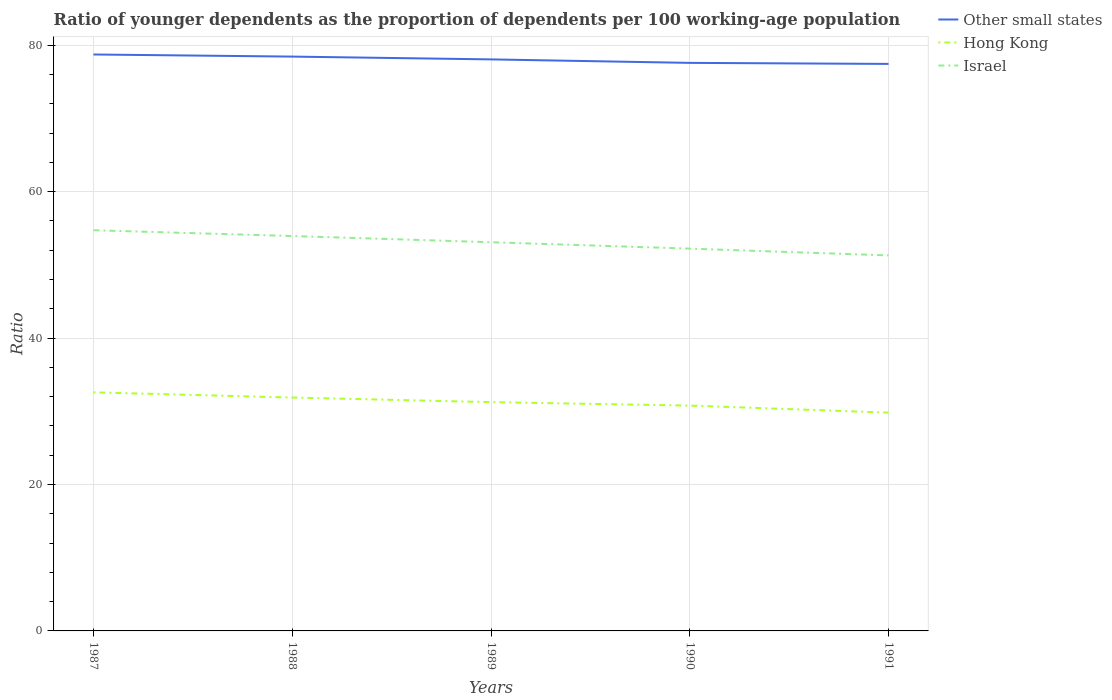Does the line corresponding to Hong Kong intersect with the line corresponding to Israel?
Ensure brevity in your answer.  No. Across all years, what is the maximum age dependency ratio(young) in Other small states?
Provide a short and direct response. 77.45. What is the total age dependency ratio(young) in Israel in the graph?
Ensure brevity in your answer.  2.65. What is the difference between the highest and the second highest age dependency ratio(young) in Israel?
Provide a short and direct response. 3.44. Is the age dependency ratio(young) in Israel strictly greater than the age dependency ratio(young) in Other small states over the years?
Give a very brief answer. Yes. How many lines are there?
Your answer should be compact. 3. How many years are there in the graph?
Offer a very short reply. 5. Are the values on the major ticks of Y-axis written in scientific E-notation?
Provide a short and direct response. No. Does the graph contain any zero values?
Keep it short and to the point. No. Where does the legend appear in the graph?
Give a very brief answer. Top right. How are the legend labels stacked?
Offer a very short reply. Vertical. What is the title of the graph?
Provide a succinct answer. Ratio of younger dependents as the proportion of dependents per 100 working-age population. What is the label or title of the Y-axis?
Your response must be concise. Ratio. What is the Ratio in Other small states in 1987?
Ensure brevity in your answer.  78.74. What is the Ratio in Hong Kong in 1987?
Give a very brief answer. 32.59. What is the Ratio of Israel in 1987?
Your answer should be compact. 54.73. What is the Ratio in Other small states in 1988?
Make the answer very short. 78.45. What is the Ratio in Hong Kong in 1988?
Offer a terse response. 31.88. What is the Ratio of Israel in 1988?
Offer a terse response. 53.94. What is the Ratio of Other small states in 1989?
Your answer should be very brief. 78.07. What is the Ratio of Hong Kong in 1989?
Your answer should be very brief. 31.25. What is the Ratio in Israel in 1989?
Your answer should be very brief. 53.09. What is the Ratio in Other small states in 1990?
Your response must be concise. 77.59. What is the Ratio of Hong Kong in 1990?
Ensure brevity in your answer.  30.78. What is the Ratio in Israel in 1990?
Your response must be concise. 52.22. What is the Ratio of Other small states in 1991?
Offer a very short reply. 77.45. What is the Ratio of Hong Kong in 1991?
Your answer should be compact. 29.82. What is the Ratio of Israel in 1991?
Offer a very short reply. 51.29. Across all years, what is the maximum Ratio of Other small states?
Your answer should be very brief. 78.74. Across all years, what is the maximum Ratio of Hong Kong?
Ensure brevity in your answer.  32.59. Across all years, what is the maximum Ratio in Israel?
Provide a succinct answer. 54.73. Across all years, what is the minimum Ratio in Other small states?
Offer a very short reply. 77.45. Across all years, what is the minimum Ratio in Hong Kong?
Provide a short and direct response. 29.82. Across all years, what is the minimum Ratio in Israel?
Give a very brief answer. 51.29. What is the total Ratio in Other small states in the graph?
Your response must be concise. 390.29. What is the total Ratio of Hong Kong in the graph?
Offer a terse response. 156.31. What is the total Ratio of Israel in the graph?
Give a very brief answer. 265.27. What is the difference between the Ratio in Other small states in 1987 and that in 1988?
Offer a very short reply. 0.29. What is the difference between the Ratio in Hong Kong in 1987 and that in 1988?
Your response must be concise. 0.71. What is the difference between the Ratio of Israel in 1987 and that in 1988?
Provide a succinct answer. 0.79. What is the difference between the Ratio in Other small states in 1987 and that in 1989?
Provide a succinct answer. 0.67. What is the difference between the Ratio of Hong Kong in 1987 and that in 1989?
Offer a very short reply. 1.34. What is the difference between the Ratio in Israel in 1987 and that in 1989?
Provide a succinct answer. 1.64. What is the difference between the Ratio of Other small states in 1987 and that in 1990?
Keep it short and to the point. 1.15. What is the difference between the Ratio in Hong Kong in 1987 and that in 1990?
Provide a succinct answer. 1.81. What is the difference between the Ratio of Israel in 1987 and that in 1990?
Give a very brief answer. 2.51. What is the difference between the Ratio in Other small states in 1987 and that in 1991?
Provide a short and direct response. 1.29. What is the difference between the Ratio in Hong Kong in 1987 and that in 1991?
Offer a very short reply. 2.77. What is the difference between the Ratio of Israel in 1987 and that in 1991?
Offer a very short reply. 3.44. What is the difference between the Ratio in Other small states in 1988 and that in 1989?
Ensure brevity in your answer.  0.38. What is the difference between the Ratio in Hong Kong in 1988 and that in 1989?
Provide a succinct answer. 0.63. What is the difference between the Ratio in Israel in 1988 and that in 1989?
Provide a succinct answer. 0.85. What is the difference between the Ratio of Hong Kong in 1988 and that in 1990?
Your answer should be compact. 1.1. What is the difference between the Ratio in Israel in 1988 and that in 1990?
Your answer should be very brief. 1.72. What is the difference between the Ratio in Other small states in 1988 and that in 1991?
Offer a very short reply. 1. What is the difference between the Ratio in Hong Kong in 1988 and that in 1991?
Provide a succinct answer. 2.06. What is the difference between the Ratio in Israel in 1988 and that in 1991?
Your answer should be compact. 2.65. What is the difference between the Ratio of Other small states in 1989 and that in 1990?
Your answer should be compact. 0.48. What is the difference between the Ratio of Hong Kong in 1989 and that in 1990?
Your answer should be very brief. 0.47. What is the difference between the Ratio of Israel in 1989 and that in 1990?
Provide a succinct answer. 0.87. What is the difference between the Ratio of Other small states in 1989 and that in 1991?
Offer a very short reply. 0.62. What is the difference between the Ratio in Hong Kong in 1989 and that in 1991?
Your answer should be very brief. 1.43. What is the difference between the Ratio in Israel in 1989 and that in 1991?
Your response must be concise. 1.8. What is the difference between the Ratio of Other small states in 1990 and that in 1991?
Provide a short and direct response. 0.14. What is the difference between the Ratio of Hong Kong in 1990 and that in 1991?
Give a very brief answer. 0.96. What is the difference between the Ratio of Israel in 1990 and that in 1991?
Make the answer very short. 0.93. What is the difference between the Ratio of Other small states in 1987 and the Ratio of Hong Kong in 1988?
Your answer should be compact. 46.86. What is the difference between the Ratio in Other small states in 1987 and the Ratio in Israel in 1988?
Your response must be concise. 24.8. What is the difference between the Ratio in Hong Kong in 1987 and the Ratio in Israel in 1988?
Make the answer very short. -21.35. What is the difference between the Ratio of Other small states in 1987 and the Ratio of Hong Kong in 1989?
Your answer should be compact. 47.49. What is the difference between the Ratio of Other small states in 1987 and the Ratio of Israel in 1989?
Offer a terse response. 25.64. What is the difference between the Ratio in Hong Kong in 1987 and the Ratio in Israel in 1989?
Offer a very short reply. -20.5. What is the difference between the Ratio of Other small states in 1987 and the Ratio of Hong Kong in 1990?
Offer a terse response. 47.96. What is the difference between the Ratio in Other small states in 1987 and the Ratio in Israel in 1990?
Give a very brief answer. 26.52. What is the difference between the Ratio in Hong Kong in 1987 and the Ratio in Israel in 1990?
Give a very brief answer. -19.63. What is the difference between the Ratio in Other small states in 1987 and the Ratio in Hong Kong in 1991?
Your answer should be compact. 48.92. What is the difference between the Ratio of Other small states in 1987 and the Ratio of Israel in 1991?
Make the answer very short. 27.45. What is the difference between the Ratio of Hong Kong in 1987 and the Ratio of Israel in 1991?
Provide a succinct answer. -18.7. What is the difference between the Ratio in Other small states in 1988 and the Ratio in Hong Kong in 1989?
Your answer should be compact. 47.2. What is the difference between the Ratio of Other small states in 1988 and the Ratio of Israel in 1989?
Keep it short and to the point. 25.36. What is the difference between the Ratio of Hong Kong in 1988 and the Ratio of Israel in 1989?
Your response must be concise. -21.21. What is the difference between the Ratio in Other small states in 1988 and the Ratio in Hong Kong in 1990?
Make the answer very short. 47.67. What is the difference between the Ratio of Other small states in 1988 and the Ratio of Israel in 1990?
Give a very brief answer. 26.23. What is the difference between the Ratio in Hong Kong in 1988 and the Ratio in Israel in 1990?
Offer a very short reply. -20.34. What is the difference between the Ratio in Other small states in 1988 and the Ratio in Hong Kong in 1991?
Your answer should be compact. 48.63. What is the difference between the Ratio of Other small states in 1988 and the Ratio of Israel in 1991?
Provide a succinct answer. 27.16. What is the difference between the Ratio in Hong Kong in 1988 and the Ratio in Israel in 1991?
Your answer should be very brief. -19.41. What is the difference between the Ratio in Other small states in 1989 and the Ratio in Hong Kong in 1990?
Give a very brief answer. 47.29. What is the difference between the Ratio in Other small states in 1989 and the Ratio in Israel in 1990?
Provide a succinct answer. 25.85. What is the difference between the Ratio in Hong Kong in 1989 and the Ratio in Israel in 1990?
Offer a very short reply. -20.97. What is the difference between the Ratio of Other small states in 1989 and the Ratio of Hong Kong in 1991?
Give a very brief answer. 48.25. What is the difference between the Ratio in Other small states in 1989 and the Ratio in Israel in 1991?
Offer a very short reply. 26.78. What is the difference between the Ratio in Hong Kong in 1989 and the Ratio in Israel in 1991?
Offer a very short reply. -20.04. What is the difference between the Ratio of Other small states in 1990 and the Ratio of Hong Kong in 1991?
Keep it short and to the point. 47.77. What is the difference between the Ratio in Other small states in 1990 and the Ratio in Israel in 1991?
Provide a succinct answer. 26.3. What is the difference between the Ratio in Hong Kong in 1990 and the Ratio in Israel in 1991?
Your answer should be very brief. -20.51. What is the average Ratio in Other small states per year?
Offer a terse response. 78.06. What is the average Ratio of Hong Kong per year?
Make the answer very short. 31.26. What is the average Ratio in Israel per year?
Your answer should be very brief. 53.05. In the year 1987, what is the difference between the Ratio of Other small states and Ratio of Hong Kong?
Offer a very short reply. 46.15. In the year 1987, what is the difference between the Ratio in Other small states and Ratio in Israel?
Give a very brief answer. 24.01. In the year 1987, what is the difference between the Ratio of Hong Kong and Ratio of Israel?
Offer a terse response. -22.14. In the year 1988, what is the difference between the Ratio in Other small states and Ratio in Hong Kong?
Offer a very short reply. 46.57. In the year 1988, what is the difference between the Ratio of Other small states and Ratio of Israel?
Provide a short and direct response. 24.51. In the year 1988, what is the difference between the Ratio of Hong Kong and Ratio of Israel?
Offer a terse response. -22.06. In the year 1989, what is the difference between the Ratio in Other small states and Ratio in Hong Kong?
Provide a short and direct response. 46.82. In the year 1989, what is the difference between the Ratio of Other small states and Ratio of Israel?
Make the answer very short. 24.97. In the year 1989, what is the difference between the Ratio of Hong Kong and Ratio of Israel?
Keep it short and to the point. -21.84. In the year 1990, what is the difference between the Ratio in Other small states and Ratio in Hong Kong?
Your response must be concise. 46.81. In the year 1990, what is the difference between the Ratio in Other small states and Ratio in Israel?
Make the answer very short. 25.37. In the year 1990, what is the difference between the Ratio of Hong Kong and Ratio of Israel?
Keep it short and to the point. -21.44. In the year 1991, what is the difference between the Ratio of Other small states and Ratio of Hong Kong?
Make the answer very short. 47.63. In the year 1991, what is the difference between the Ratio in Other small states and Ratio in Israel?
Your answer should be very brief. 26.16. In the year 1991, what is the difference between the Ratio of Hong Kong and Ratio of Israel?
Offer a very short reply. -21.47. What is the ratio of the Ratio in Other small states in 1987 to that in 1988?
Keep it short and to the point. 1. What is the ratio of the Ratio in Hong Kong in 1987 to that in 1988?
Your answer should be very brief. 1.02. What is the ratio of the Ratio in Israel in 1987 to that in 1988?
Provide a short and direct response. 1.01. What is the ratio of the Ratio in Other small states in 1987 to that in 1989?
Make the answer very short. 1.01. What is the ratio of the Ratio in Hong Kong in 1987 to that in 1989?
Offer a very short reply. 1.04. What is the ratio of the Ratio of Israel in 1987 to that in 1989?
Your answer should be very brief. 1.03. What is the ratio of the Ratio of Other small states in 1987 to that in 1990?
Make the answer very short. 1.01. What is the ratio of the Ratio of Hong Kong in 1987 to that in 1990?
Your answer should be compact. 1.06. What is the ratio of the Ratio of Israel in 1987 to that in 1990?
Offer a terse response. 1.05. What is the ratio of the Ratio in Other small states in 1987 to that in 1991?
Offer a very short reply. 1.02. What is the ratio of the Ratio of Hong Kong in 1987 to that in 1991?
Provide a succinct answer. 1.09. What is the ratio of the Ratio in Israel in 1987 to that in 1991?
Keep it short and to the point. 1.07. What is the ratio of the Ratio of Other small states in 1988 to that in 1989?
Provide a succinct answer. 1. What is the ratio of the Ratio of Hong Kong in 1988 to that in 1989?
Your answer should be compact. 1.02. What is the ratio of the Ratio in Israel in 1988 to that in 1989?
Your response must be concise. 1.02. What is the ratio of the Ratio of Other small states in 1988 to that in 1990?
Keep it short and to the point. 1.01. What is the ratio of the Ratio of Hong Kong in 1988 to that in 1990?
Your answer should be compact. 1.04. What is the ratio of the Ratio of Israel in 1988 to that in 1990?
Keep it short and to the point. 1.03. What is the ratio of the Ratio in Other small states in 1988 to that in 1991?
Your response must be concise. 1.01. What is the ratio of the Ratio of Hong Kong in 1988 to that in 1991?
Your response must be concise. 1.07. What is the ratio of the Ratio of Israel in 1988 to that in 1991?
Keep it short and to the point. 1.05. What is the ratio of the Ratio in Other small states in 1989 to that in 1990?
Offer a terse response. 1.01. What is the ratio of the Ratio of Hong Kong in 1989 to that in 1990?
Give a very brief answer. 1.02. What is the ratio of the Ratio of Israel in 1989 to that in 1990?
Make the answer very short. 1.02. What is the ratio of the Ratio in Hong Kong in 1989 to that in 1991?
Offer a very short reply. 1.05. What is the ratio of the Ratio in Israel in 1989 to that in 1991?
Your response must be concise. 1.04. What is the ratio of the Ratio in Hong Kong in 1990 to that in 1991?
Provide a succinct answer. 1.03. What is the ratio of the Ratio in Israel in 1990 to that in 1991?
Your answer should be compact. 1.02. What is the difference between the highest and the second highest Ratio in Other small states?
Make the answer very short. 0.29. What is the difference between the highest and the second highest Ratio of Hong Kong?
Provide a succinct answer. 0.71. What is the difference between the highest and the second highest Ratio in Israel?
Give a very brief answer. 0.79. What is the difference between the highest and the lowest Ratio in Other small states?
Offer a very short reply. 1.29. What is the difference between the highest and the lowest Ratio in Hong Kong?
Offer a terse response. 2.77. What is the difference between the highest and the lowest Ratio of Israel?
Keep it short and to the point. 3.44. 